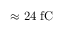Convert formula to latex. <formula><loc_0><loc_0><loc_500><loc_500>\approx 2 4 f C</formula> 